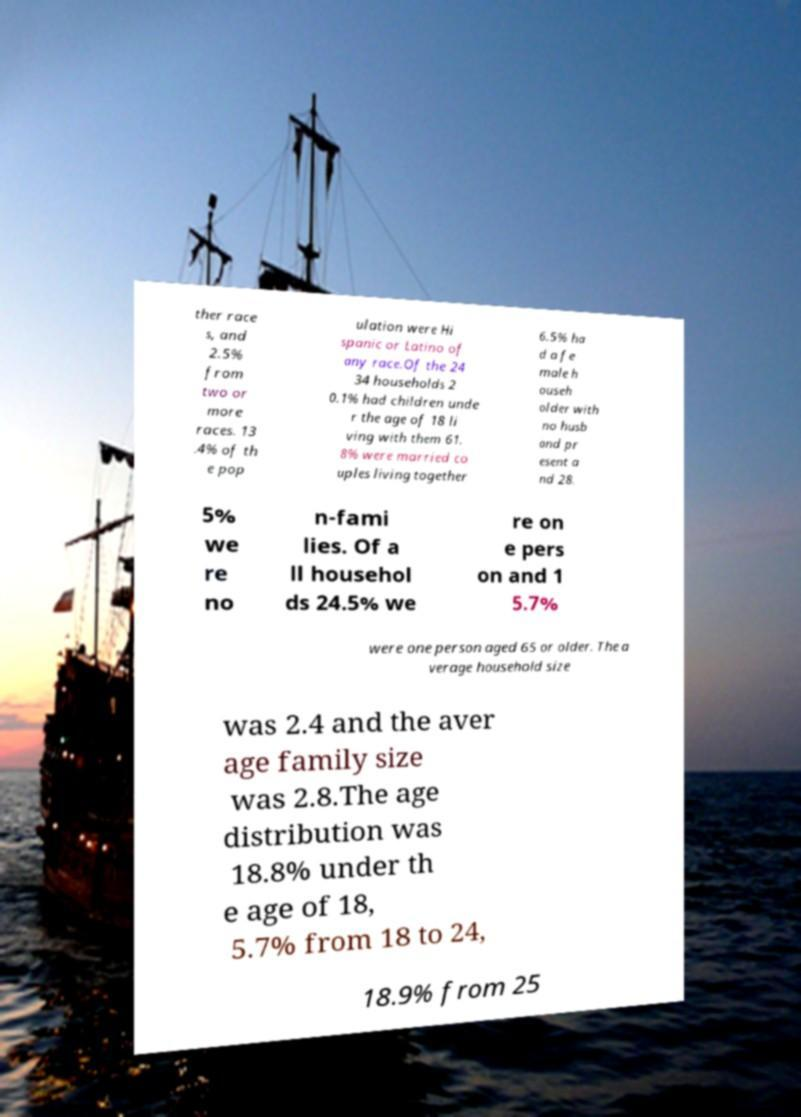Could you assist in decoding the text presented in this image and type it out clearly? ther race s, and 2.5% from two or more races. 13 .4% of th e pop ulation were Hi spanic or Latino of any race.Of the 24 34 households 2 0.1% had children unde r the age of 18 li ving with them 61. 8% were married co uples living together 6.5% ha d a fe male h ouseh older with no husb and pr esent a nd 28. 5% we re no n-fami lies. Of a ll househol ds 24.5% we re on e pers on and 1 5.7% were one person aged 65 or older. The a verage household size was 2.4 and the aver age family size was 2.8.The age distribution was 18.8% under th e age of 18, 5.7% from 18 to 24, 18.9% from 25 